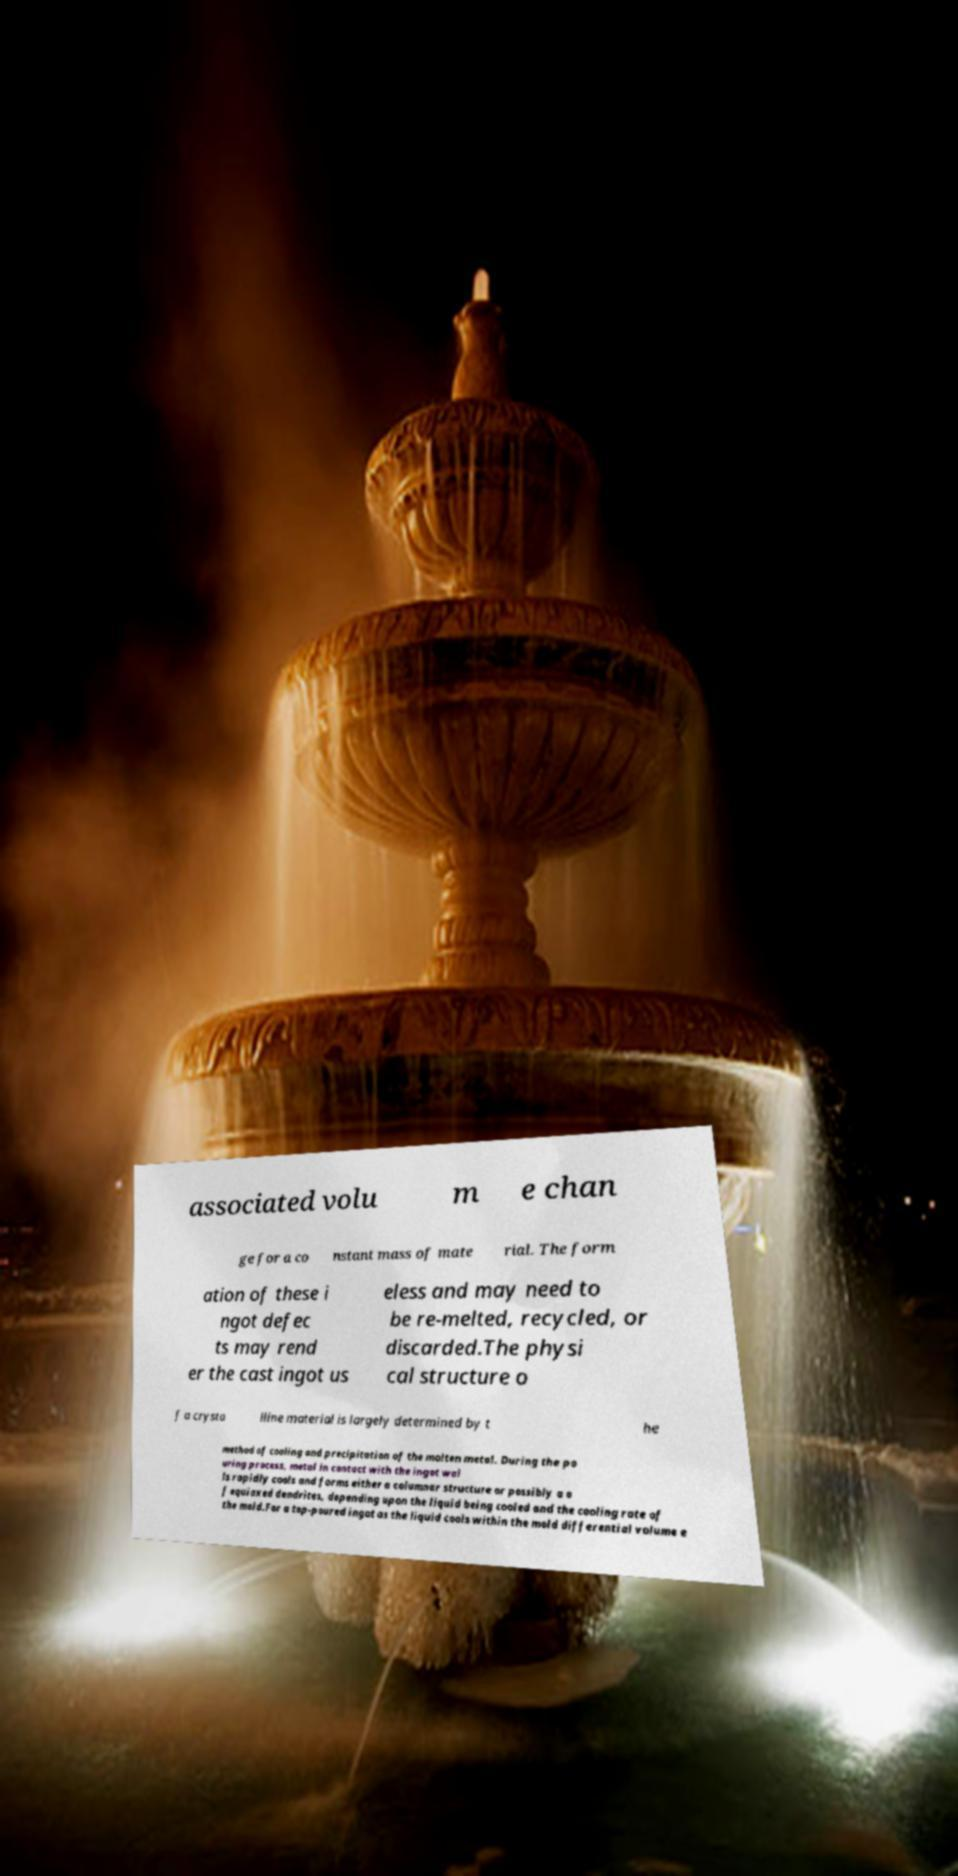I need the written content from this picture converted into text. Can you do that? associated volu m e chan ge for a co nstant mass of mate rial. The form ation of these i ngot defec ts may rend er the cast ingot us eless and may need to be re-melted, recycled, or discarded.The physi cal structure o f a crysta lline material is largely determined by t he method of cooling and precipitation of the molten metal. During the po uring process, metal in contact with the ingot wal ls rapidly cools and forms either a columnar structure or possibly a o f equiaxed dendrites, depending upon the liquid being cooled and the cooling rate of the mold.For a top-poured ingot as the liquid cools within the mold differential volume e 